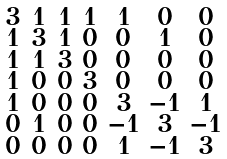<formula> <loc_0><loc_0><loc_500><loc_500>\begin{smallmatrix} 3 & 1 & 1 & 1 & 1 & 0 & 0 \\ 1 & 3 & 1 & 0 & 0 & 1 & 0 \\ 1 & 1 & 3 & 0 & 0 & 0 & 0 \\ 1 & 0 & 0 & 3 & 0 & 0 & 0 \\ 1 & 0 & 0 & 0 & 3 & - 1 & 1 \\ 0 & 1 & 0 & 0 & - 1 & 3 & - 1 \\ 0 & 0 & 0 & 0 & 1 & - 1 & 3 \end{smallmatrix}</formula> 